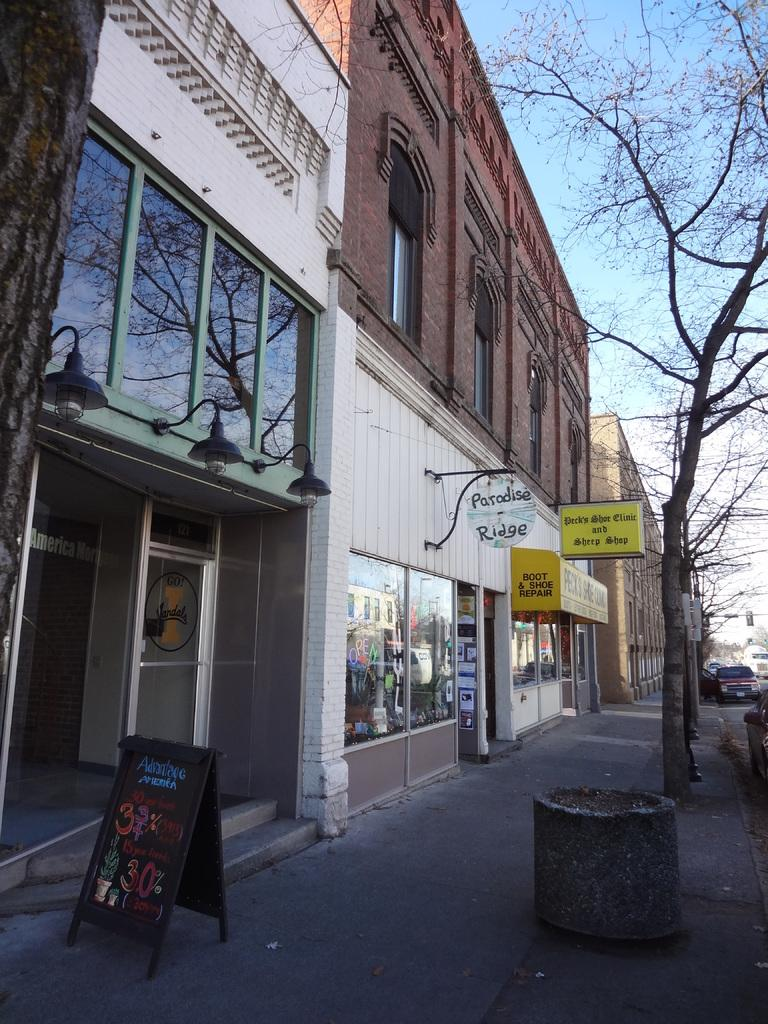What type of structure is visible in the image? There is a building in the image. What feature can be seen on the building? The building has windows. What object is present in the image, separate from the building? There is a board in the image. Can you describe the lighting in the image? There is a light in the image. How can someone access the building in the image? There are stairs in the image. What type of path is visible in the image? There is a footpath in the image. What natural element is present in the image? There is a tree in the image. What is the color of the sky in the image? The sky is pale blue in the image. What else can be seen in the image, besides the building and its surroundings? There are vehicles in the image. What type of basketball hobby is being practiced at the party in the image? There is no basketball, hobby, or party present in the image. 